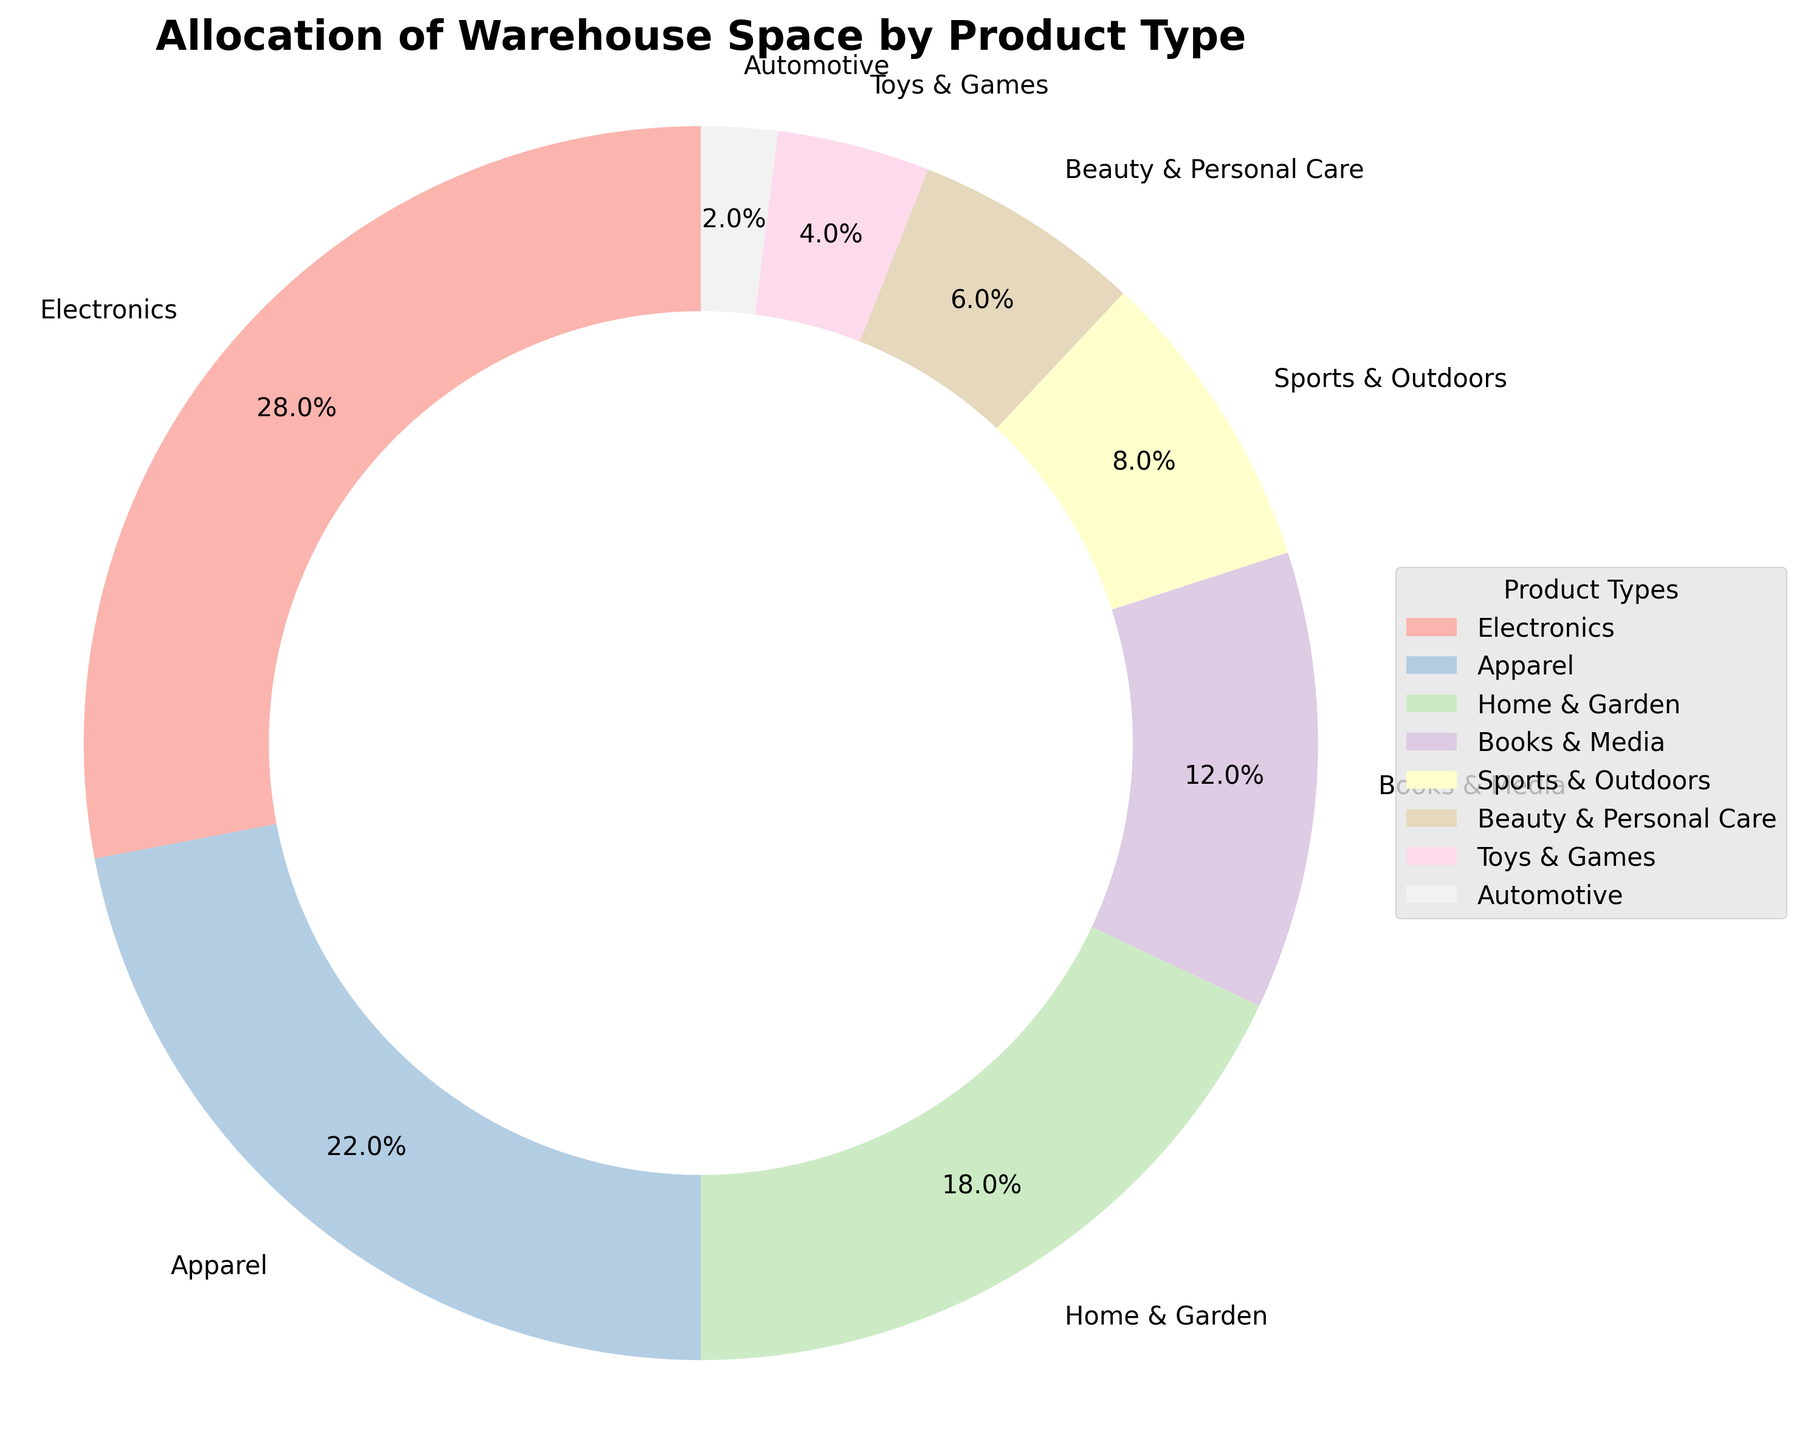Which product type occupies the most warehouse space? View the segments of the pie chart and identify the largest one which corresponds to "Electronics".
Answer: Electronics How much more space does Home & Garden take compared to Automotive? Look at the values: Home & Garden is 18%, and Automotive is 2%. Calculate the difference: 18% - 2% = 16%.
Answer: 16% What is the combined space allocation for Apparel and Sports & Outdoors? Sum the percentages for Apparel (22%) and Sports & Outdoors (8%): 22% + 8% = 30%.
Answer: 30% Which product types have less than 10% allocation space? Identify segments with less than 10%: Sports & Outdoors (8%), Beauty & Personal Care (6%), Toys & Games (4%), and Automotive (2%).
Answer: Sports & Outdoors, Beauty & Personal Care, Toys & Games, Automotive What is the space allocation difference between the largest and smallest product types? Identify the largest (Electronics, 28%) and smallest (Automotive, 2%) product types and calculate the difference: 28% - 2% = 26%.
Answer: 26% What is the average space allocation for Electronics, Apparel, and Home & Garden? Sum the percentages for Electronics (28%), Apparel (22%), and Home & Garden (18%): 28% + 22% + 18% = 68%, then divide by 3: 68% / 3 ≈ 22.67%.
Answer: 22.67% Are there more product types with space above or below 10% allocation? Count the product types above 10% (Electronics, Apparel, Home & Garden, Books & Media: 4) and below 10% (Sports & Outdoors, Beauty & Personal Care, Toys & Games, Automotive: 4). They are equal.
Answer: Equal What is the percentage of space allocated to Books & Media relative to Home & Garden? Look at the values: Books & Media is 12%, Home & Garden is 18%. Divide the Books & Media value by the Home & Garden value: 12% / 18% ≈ 0.67.
Answer: 0.67 or 67% Which color represents the segment for Apparel? Identify the segment labeled "Apparel" and observe its color, which is the second lightest shade in the pastel color palette used.
Answer: Light pink 